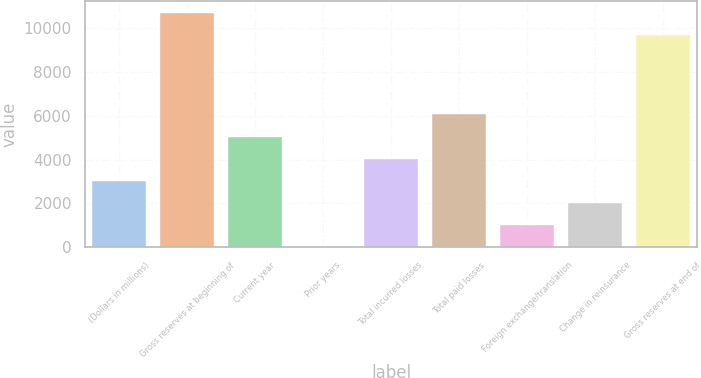Convert chart. <chart><loc_0><loc_0><loc_500><loc_500><bar_chart><fcel>(Dollars in millions)<fcel>Gross reserves at beginning of<fcel>Current year<fcel>Prior years<fcel>Total incurred losses<fcel>Total paid losses<fcel>Foreign exchange/translation<fcel>Change in reinsurance<fcel>Gross reserves at end of<nl><fcel>3033.47<fcel>10678.3<fcel>5043.65<fcel>18.2<fcel>4038.56<fcel>6048.74<fcel>1023.29<fcel>2028.38<fcel>9673.2<nl></chart> 